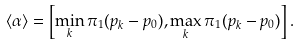<formula> <loc_0><loc_0><loc_500><loc_500>\langle \alpha \rangle = \left [ \min _ { k } \pi _ { 1 } ( p _ { k } - p _ { 0 } ) , \max _ { k } \pi _ { 1 } ( p _ { k } - p _ { 0 } ) \right ] .</formula> 